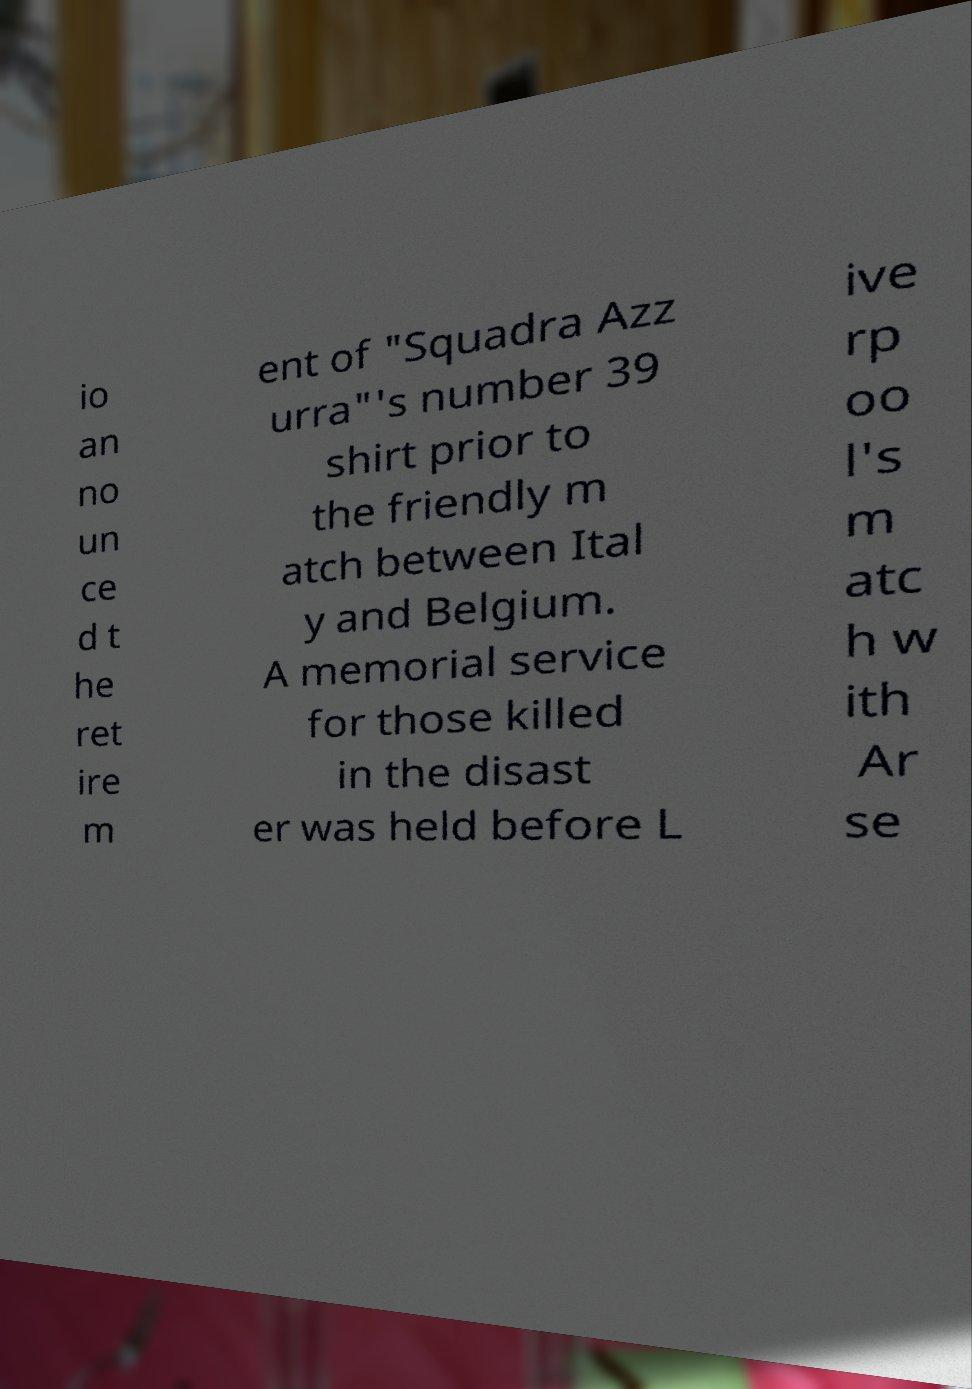I need the written content from this picture converted into text. Can you do that? io an no un ce d t he ret ire m ent of "Squadra Azz urra"'s number 39 shirt prior to the friendly m atch between Ital y and Belgium. A memorial service for those killed in the disast er was held before L ive rp oo l's m atc h w ith Ar se 